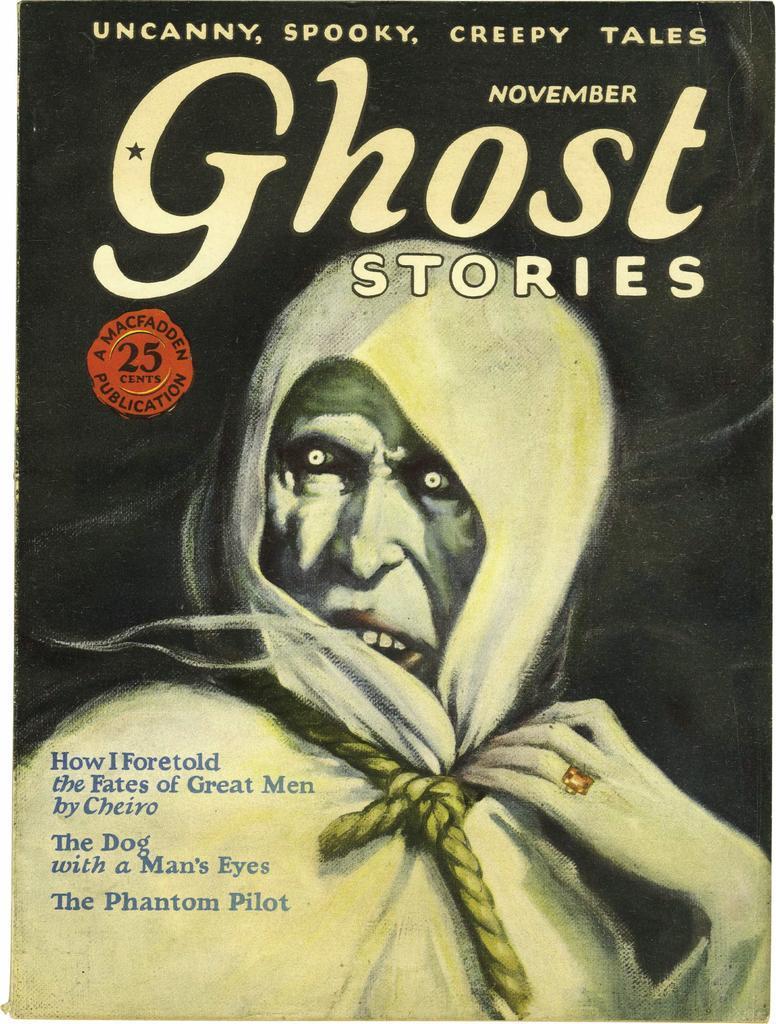In one or two sentences, can you explain what this image depicts? We can see poster,on this poster we can see a person and text. 